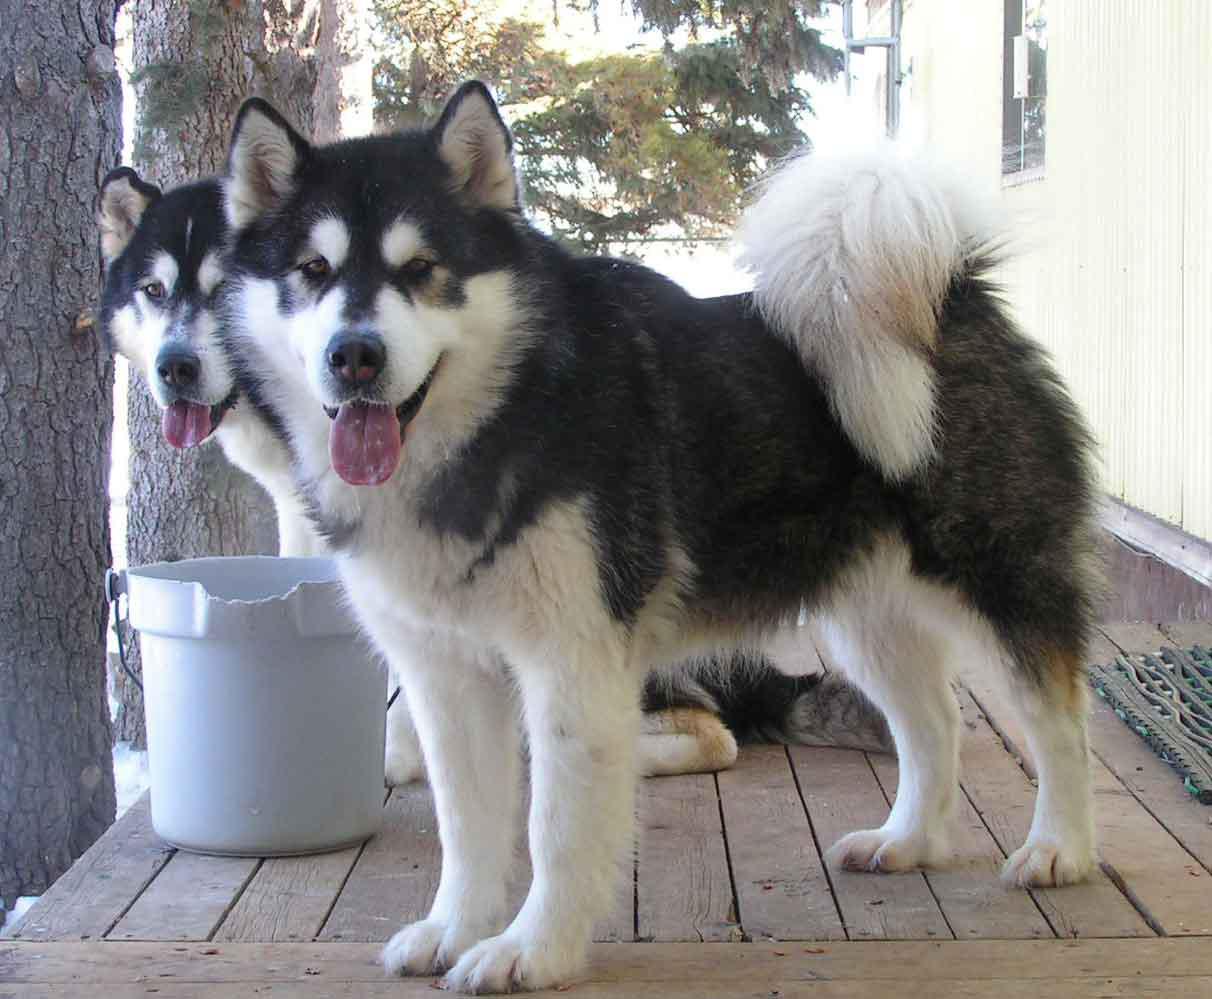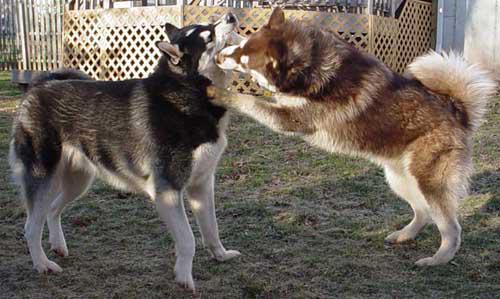The first image is the image on the left, the second image is the image on the right. Analyze the images presented: Is the assertion "There are four dogs." valid? Answer yes or no. Yes. The first image is the image on the left, the second image is the image on the right. Assess this claim about the two images: "There is a total of four dogs.". Correct or not? Answer yes or no. Yes. 